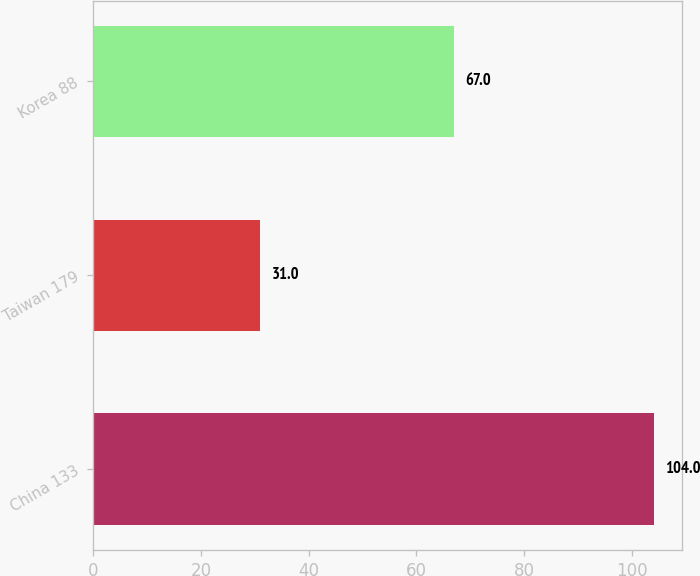Convert chart. <chart><loc_0><loc_0><loc_500><loc_500><bar_chart><fcel>China 133<fcel>Taiwan 179<fcel>Korea 88<nl><fcel>104<fcel>31<fcel>67<nl></chart> 